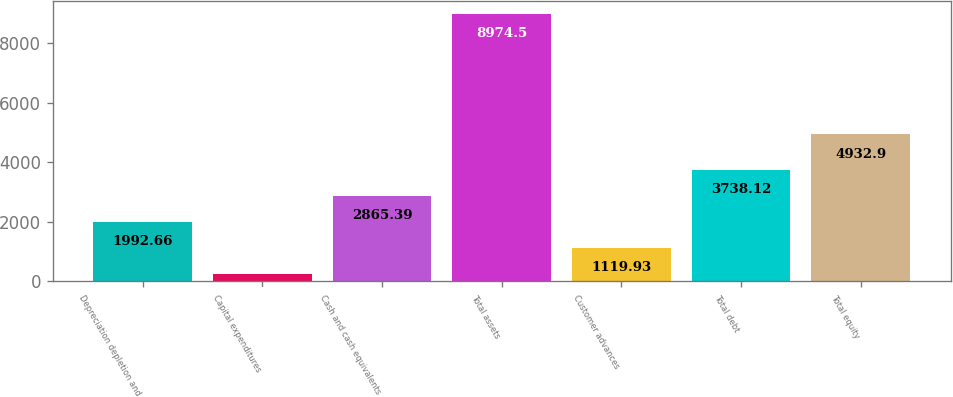<chart> <loc_0><loc_0><loc_500><loc_500><bar_chart><fcel>Depreciation depletion and<fcel>Capital expenditures<fcel>Cash and cash equivalents<fcel>Total assets<fcel>Customer advances<fcel>Total debt<fcel>Total equity<nl><fcel>1992.66<fcel>247.2<fcel>2865.39<fcel>8974.5<fcel>1119.93<fcel>3738.12<fcel>4932.9<nl></chart> 